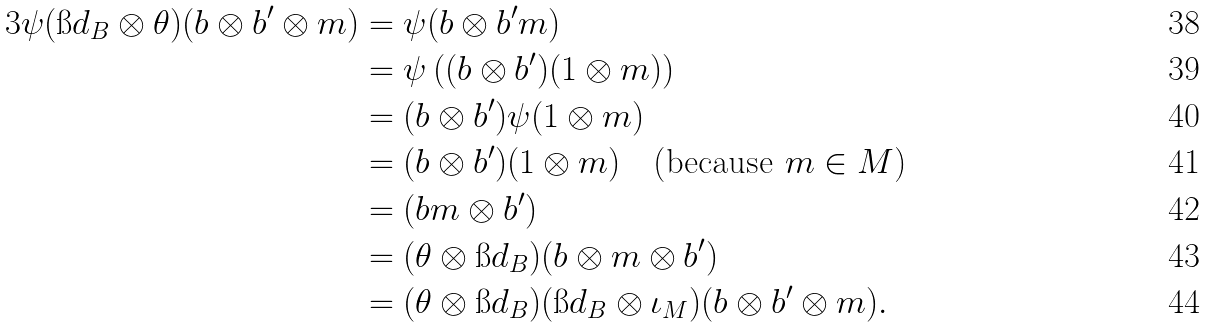Convert formula to latex. <formula><loc_0><loc_0><loc_500><loc_500>3 \psi ( \i d _ { B } \otimes \theta ) ( b \otimes b ^ { \prime } \otimes m ) & = \psi ( b \otimes b ^ { \prime } m ) \\ & = \psi \left ( ( b \otimes b ^ { \prime } ) ( 1 \otimes m ) \right ) \\ & = ( b \otimes b ^ { \prime } ) \psi ( 1 \otimes m ) \\ & = ( b \otimes b ^ { \prime } ) ( 1 \otimes m ) \quad \text {(because $m \in M$)} \\ & = ( b m \otimes b ^ { \prime } ) \\ & = ( \theta \otimes \i d _ { B } ) ( b \otimes m \otimes b ^ { \prime } ) \\ & = ( \theta \otimes \i d _ { B } ) ( \i d _ { B } \otimes \iota _ { M } ) ( b \otimes b ^ { \prime } \otimes m ) .</formula> 